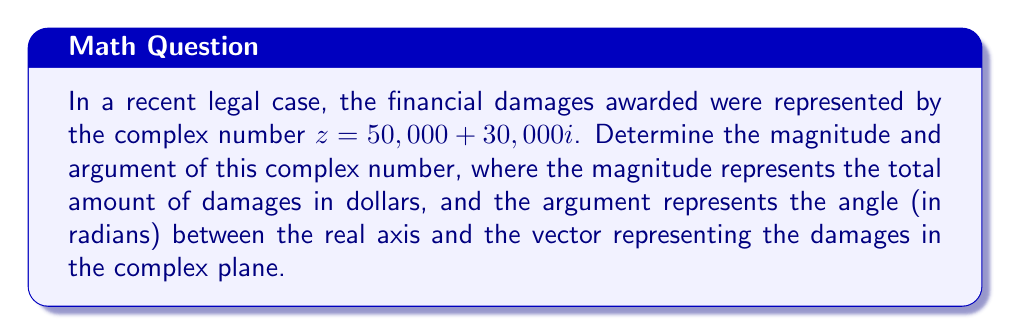What is the answer to this math problem? To find the magnitude and argument of the complex number $z = 50,000 + 30,000i$, we'll follow these steps:

1. Magnitude (|z|):
   The magnitude is calculated using the formula: $|z| = \sqrt{a^2 + b^2}$, where $a$ is the real part and $b$ is the imaginary part.
   
   $|z| = \sqrt{50,000^2 + 30,000^2}$
   $= \sqrt{2,500,000,000 + 900,000,000}$
   $= \sqrt{3,400,000,000}$
   $= 58,309.52$ (rounded to 2 decimal places)

2. Argument (arg(z)):
   The argument is calculated using the formula: $\arg(z) = \tan^{-1}(\frac{b}{a})$, where $a$ is the real part and $b$ is the imaginary part.
   
   $\arg(z) = \tan^{-1}(\frac{30,000}{50,000})$
   $= \tan^{-1}(0.6)$
   $= 0.5404$ radians (rounded to 4 decimal places)

Note: Since both the real and imaginary parts are positive, the angle is in the first quadrant, so no adjustment is needed.
Answer: Magnitude: $58,309.52, Argument: 0.5404$ radians 